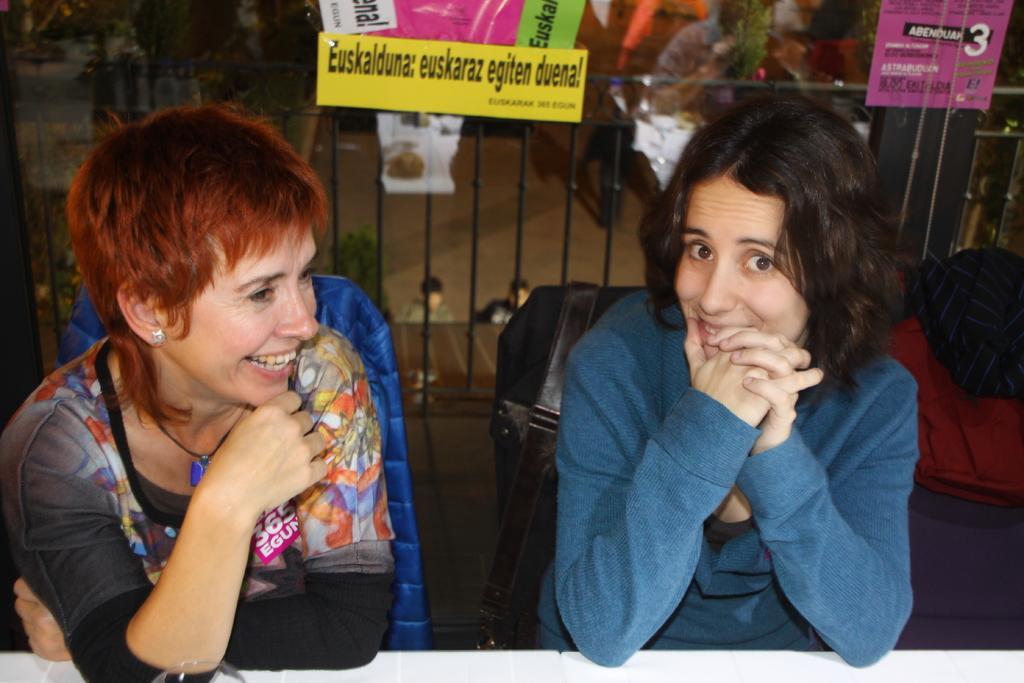Please provide a concise description of this image. In this image we can see two people sitting on the chair, beside a woman there are objects looks like bags and in the background there is an iron railing with board and text on the board and there are two people walking on the road. 